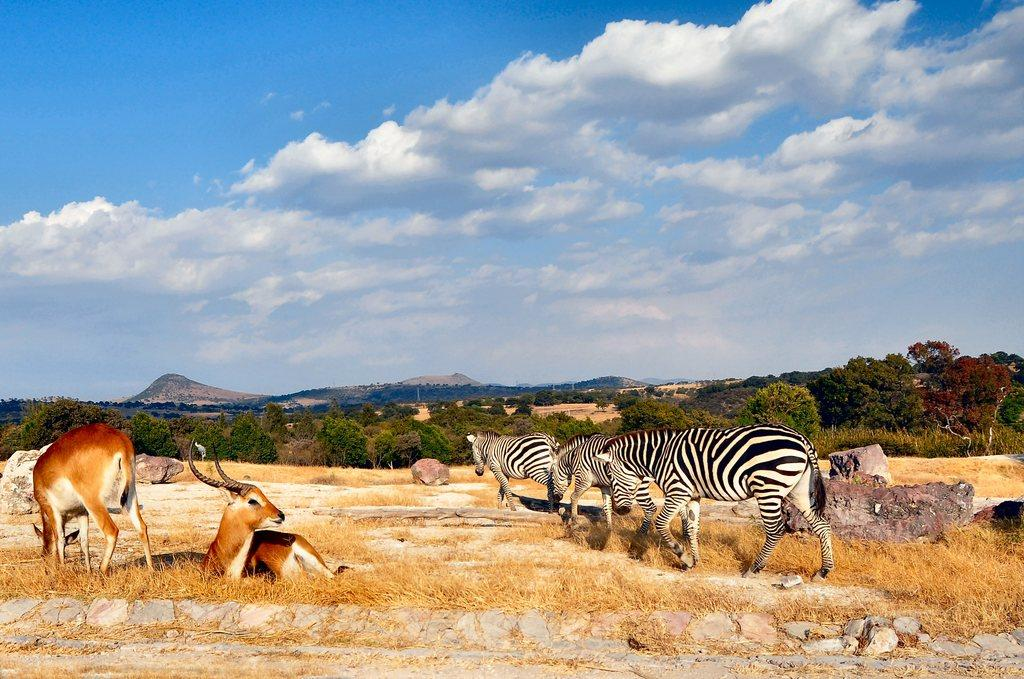What type of animals can be seen on the ground in the image? There are animals on the ground in the image, but their specific type is not mentioned in the facts. What type of vegetation is visible on the ground in the image? Dried grass is visible in the image. What other objects can be seen on the ground in the image? There are stones in the image. What can be seen in the background of the image? There are trees, mountains, and the sky visible in the background of the image. What is the condition of the sky in the image? Clouds are present in the sky in the image. How many babies are crawling on the ground in the image? There is no mention of babies in the image; it features animals on the ground. What type of ink is used to draw the mountains in the image? The image is a photograph, not a drawing, so there is no ink present. 